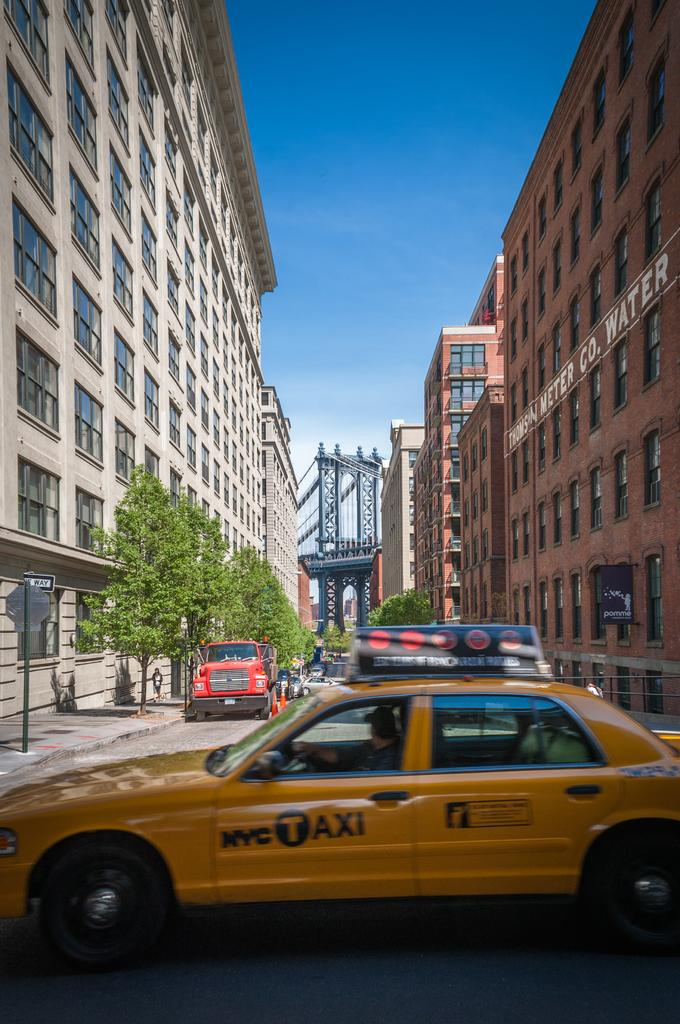<image>
Share a concise interpretation of the image provided. A NYC Taxi is driving down the street 